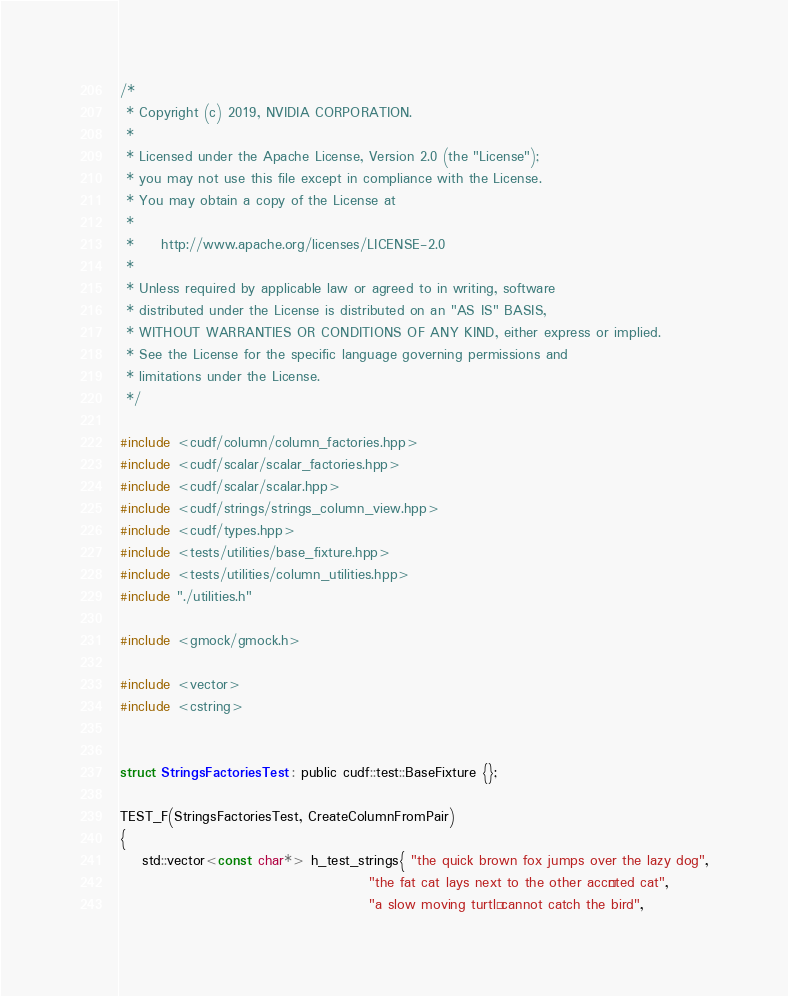<code> <loc_0><loc_0><loc_500><loc_500><_Cuda_>/*
 * Copyright (c) 2019, NVIDIA CORPORATION.
 *
 * Licensed under the Apache License, Version 2.0 (the "License");
 * you may not use this file except in compliance with the License.
 * You may obtain a copy of the License at
 *
 *     http://www.apache.org/licenses/LICENSE-2.0
 *
 * Unless required by applicable law or agreed to in writing, software
 * distributed under the License is distributed on an "AS IS" BASIS,
 * WITHOUT WARRANTIES OR CONDITIONS OF ANY KIND, either express or implied.
 * See the License for the specific language governing permissions and
 * limitations under the License.
 */

#include <cudf/column/column_factories.hpp>
#include <cudf/scalar/scalar_factories.hpp>
#include <cudf/scalar/scalar.hpp>
#include <cudf/strings/strings_column_view.hpp>
#include <cudf/types.hpp>
#include <tests/utilities/base_fixture.hpp>
#include <tests/utilities/column_utilities.hpp>
#include "./utilities.h"

#include <gmock/gmock.h>

#include <vector>
#include <cstring>


struct StringsFactoriesTest : public cudf::test::BaseFixture {};

TEST_F(StringsFactoriesTest, CreateColumnFromPair)
{
    std::vector<const char*> h_test_strings{ "the quick brown fox jumps over the lazy dog",
                                             "the fat cat lays next to the other accénted cat",
                                             "a slow moving turtlé cannot catch the bird",</code> 